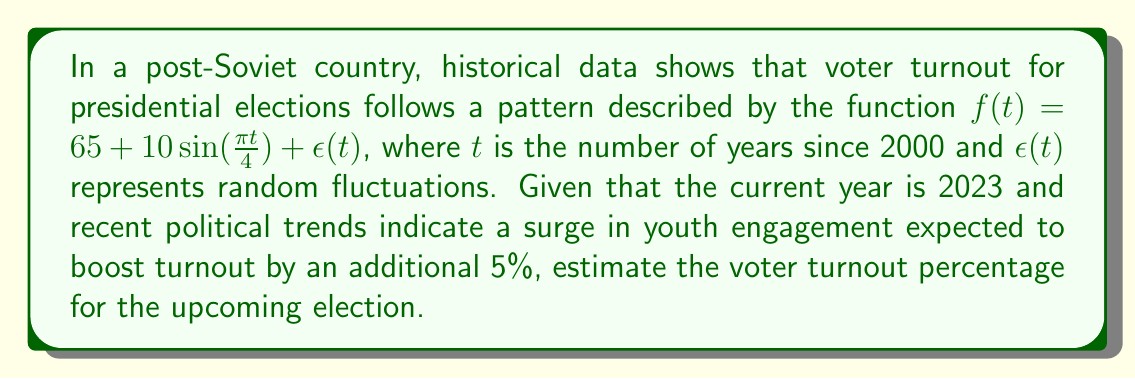Help me with this question. To solve this inverse problem, we'll follow these steps:

1. Determine the value of $t$ for 2023:
   $t = 2023 - 2000 = 23$

2. Calculate the base turnout using the given function:
   $$f(23) = 65 + 10\sin(\frac{\pi \cdot 23}{4})$$

3. Evaluate $\sin(\frac{\pi \cdot 23}{4})$:
   $$\frac{\pi \cdot 23}{4} \approx 18.0642$$
   $$\sin(18.0642) \approx -0.3191$$

4. Calculate the base turnout:
   $$f(23) = 65 + 10 \cdot (-0.3191) = 65 - 3.191 = 61.809$$

5. Add the 5% boost due to increased youth engagement:
   $$61.809 + 5 = 66.809$$

6. Round to the nearest tenth for a reasonable estimate:
   $$66.809 \approx 66.8\%$$
Answer: 66.8% 